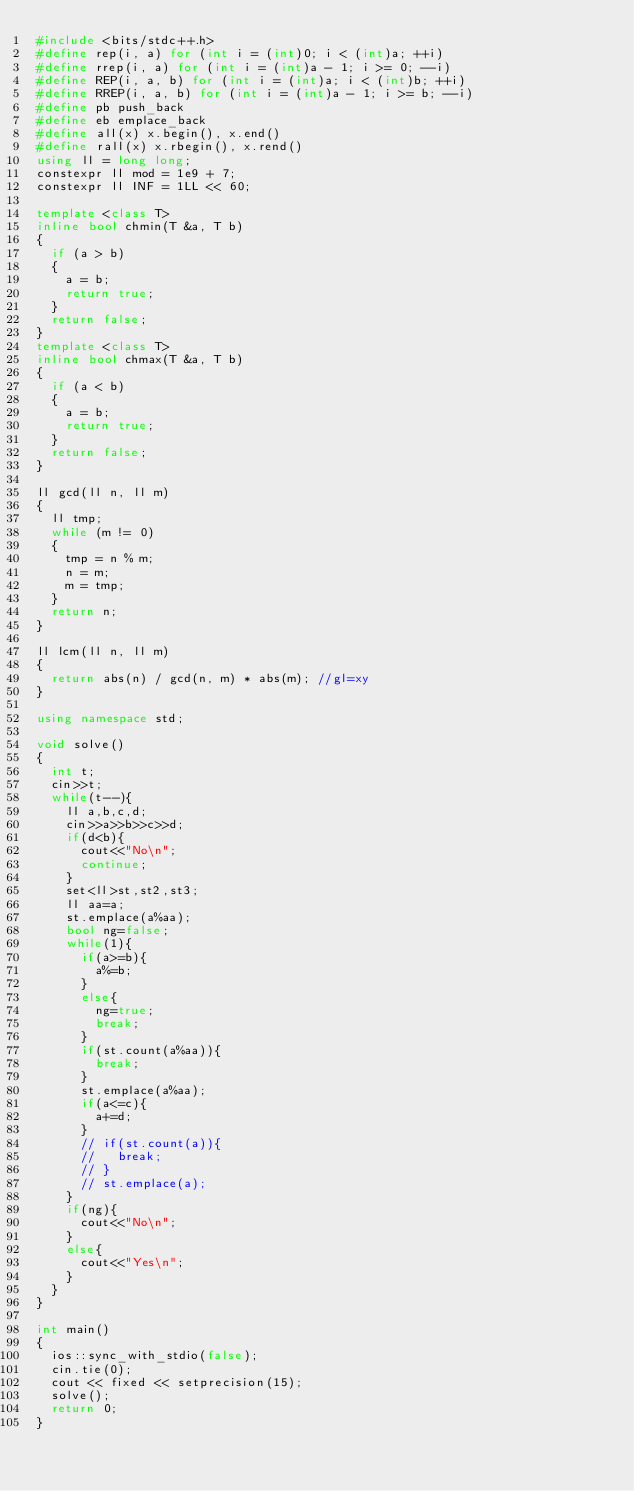<code> <loc_0><loc_0><loc_500><loc_500><_C++_>#include <bits/stdc++.h>
#define rep(i, a) for (int i = (int)0; i < (int)a; ++i)
#define rrep(i, a) for (int i = (int)a - 1; i >= 0; --i)
#define REP(i, a, b) for (int i = (int)a; i < (int)b; ++i)
#define RREP(i, a, b) for (int i = (int)a - 1; i >= b; --i)
#define pb push_back
#define eb emplace_back
#define all(x) x.begin(), x.end()
#define rall(x) x.rbegin(), x.rend()
using ll = long long;
constexpr ll mod = 1e9 + 7;
constexpr ll INF = 1LL << 60;

template <class T>
inline bool chmin(T &a, T b)
{
	if (a > b)
	{
		a = b;
		return true;
	}
	return false;
}
template <class T>
inline bool chmax(T &a, T b)
{
	if (a < b)
	{
		a = b;
		return true;
	}
	return false;
}

ll gcd(ll n, ll m)
{
	ll tmp;
	while (m != 0)
	{
		tmp = n % m;
		n = m;
		m = tmp;
	}
	return n;
}

ll lcm(ll n, ll m)
{
	return abs(n) / gcd(n, m) * abs(m); //gl=xy
}

using namespace std;

void solve()
{
  int t;
  cin>>t;
  while(t--){
    ll a,b,c,d;
    cin>>a>>b>>c>>d;
    if(d<b){
      cout<<"No\n";
      continue;
    }
    set<ll>st,st2,st3;
    ll aa=a;
    st.emplace(a%aa);
    bool ng=false;
    while(1){
      if(a>=b){
        a%=b;
      }
      else{
        ng=true;
        break;
      }
      if(st.count(a%aa)){
        break;
      }
      st.emplace(a%aa);
      if(a<=c){
        a+=d;
      }
      // if(st.count(a)){
      //   break;
      // }
      // st.emplace(a);
    }
    if(ng){
      cout<<"No\n";
    }
    else{
      cout<<"Yes\n";
    }
  }
}

int main()
{
	ios::sync_with_stdio(false);
	cin.tie(0);
	cout << fixed << setprecision(15);
	solve();
	return 0;
}
</code> 